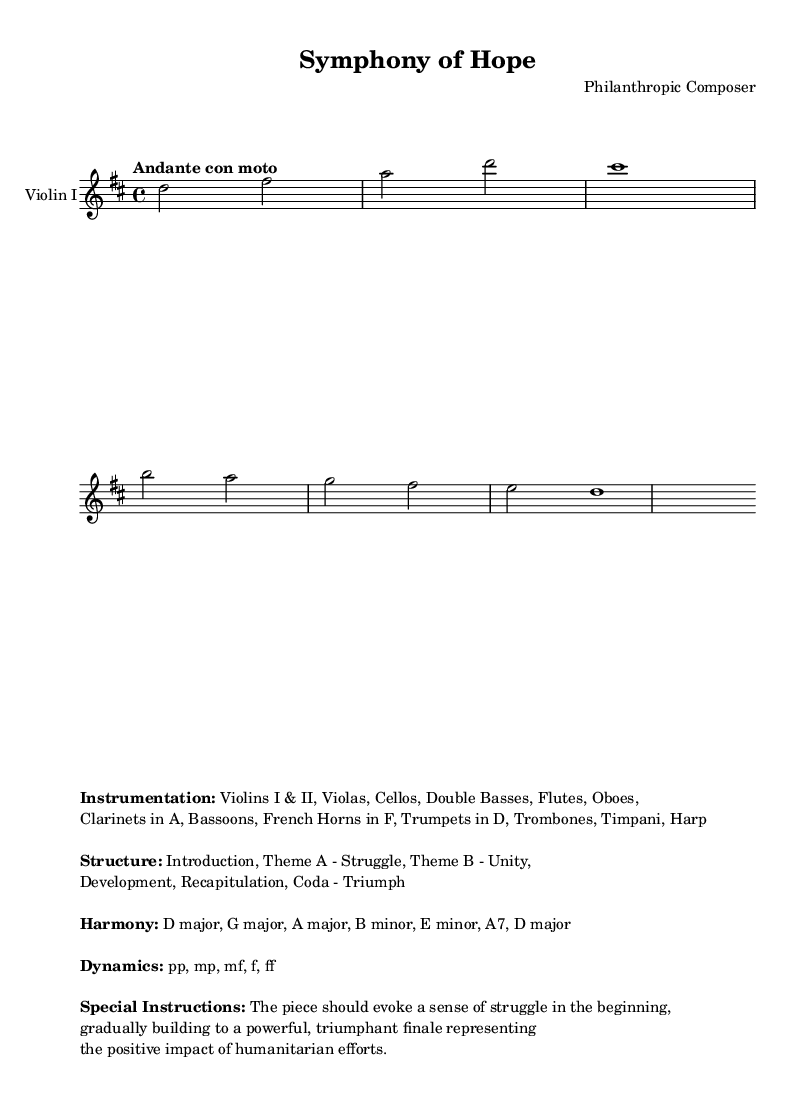What is the key signature of this music? The key signature is indicated at the beginning of the piece, showing a 'D' major key, which includes two sharps: F# and C#.
Answer: D major What is the time signature? The time signature is found in the first measure of the music, where it is indicated as '4/4', meaning there are four beats per measure, and the quarter note receives one beat.
Answer: 4/4 What is the tempo marking? The tempo can be found at the start of the score, where it states "Andante con moto", which indicates a moderately slow tempo with a bit of motion.
Answer: Andante con moto What is the structure of the piece? The structure is listed in the markup section, which outlines the parts of the piece including Introduction, Theme A - Struggle, Theme B - Unity, Development, Recapitulation, and Coda - Triumph.
Answer: Introduction, Theme A - Struggle, Theme B - Unity, Development, Recapitulation, Coda - Triumph How many instruments are included in the orchestration? The orchestration is detailed in the markup, where it lists a total of fifteen different instruments, including Violins, Violas, Cellos, and various woodwinds and brass.
Answer: 15 What does the dynamics indication suggest about the piece's expression? The dynamics notation shows various levels from pianissimo (pp) to fortissimo (ff), indicating a range of expression from very soft to very loud, suggesting a build-up of emotion towards the piece's climax.
Answer: Range: pp to ff What is the primary theme at the beginning of the piece? The primary theme is indicated as "Theme A - Struggle", suggesting that the opening section of the piece conveys a sense of conflict or difficulty before resolving into unity and triumph later.
Answer: Theme A - Struggle 